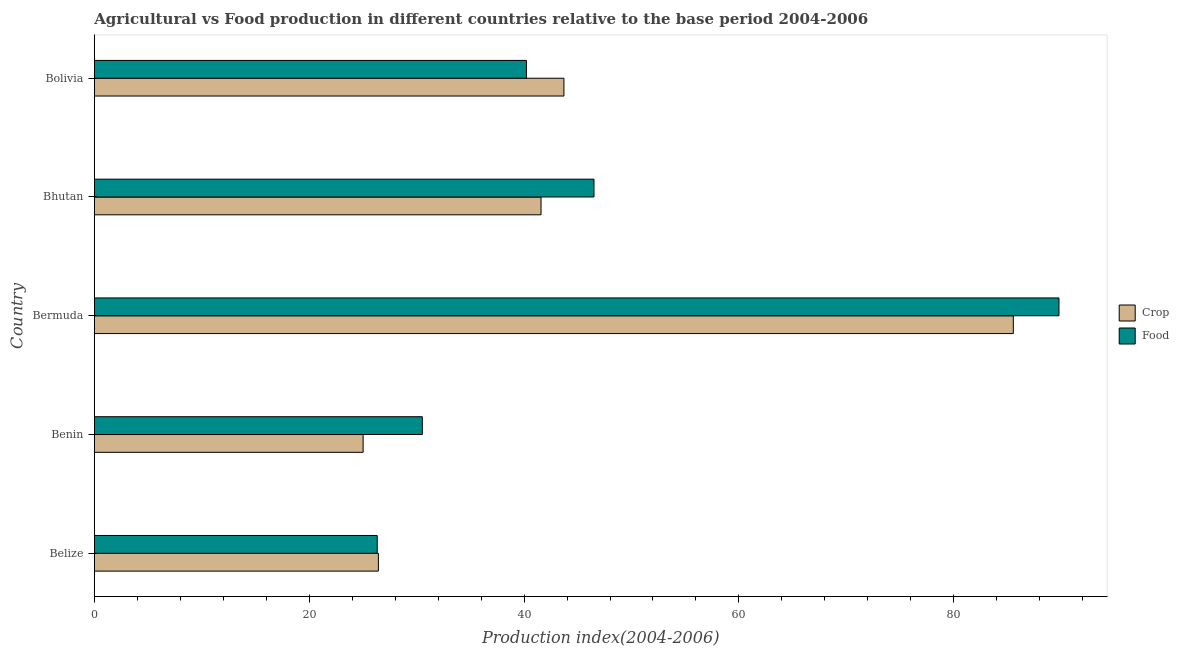How many different coloured bars are there?
Offer a terse response. 2. How many groups of bars are there?
Your response must be concise. 5. How many bars are there on the 2nd tick from the top?
Offer a terse response. 2. How many bars are there on the 1st tick from the bottom?
Offer a terse response. 2. What is the label of the 4th group of bars from the top?
Your response must be concise. Benin. What is the food production index in Benin?
Your answer should be compact. 30.53. Across all countries, what is the maximum crop production index?
Keep it short and to the point. 85.54. Across all countries, what is the minimum crop production index?
Provide a short and direct response. 25.02. In which country was the food production index maximum?
Keep it short and to the point. Bermuda. In which country was the food production index minimum?
Provide a short and direct response. Belize. What is the total crop production index in the graph?
Provide a short and direct response. 222.29. What is the difference between the food production index in Bhutan and that in Bolivia?
Give a very brief answer. 6.29. What is the difference between the food production index in Bermuda and the crop production index in Belize?
Provide a short and direct response. 63.35. What is the average food production index per country?
Your answer should be compact. 46.68. What is the difference between the food production index and crop production index in Benin?
Keep it short and to the point. 5.51. What is the ratio of the food production index in Bhutan to that in Bolivia?
Your answer should be compact. 1.16. Is the food production index in Benin less than that in Bermuda?
Give a very brief answer. Yes. What is the difference between the highest and the second highest food production index?
Provide a short and direct response. 43.28. What is the difference between the highest and the lowest crop production index?
Make the answer very short. 60.52. What does the 1st bar from the top in Bolivia represents?
Give a very brief answer. Food. What does the 1st bar from the bottom in Benin represents?
Give a very brief answer. Crop. How many bars are there?
Ensure brevity in your answer.  10. How many countries are there in the graph?
Give a very brief answer. 5. Does the graph contain any zero values?
Provide a succinct answer. No. Does the graph contain grids?
Offer a terse response. No. How many legend labels are there?
Offer a terse response. 2. What is the title of the graph?
Provide a short and direct response. Agricultural vs Food production in different countries relative to the base period 2004-2006. What is the label or title of the X-axis?
Keep it short and to the point. Production index(2004-2006). What is the Production index(2004-2006) in Crop in Belize?
Provide a short and direct response. 26.44. What is the Production index(2004-2006) in Food in Belize?
Give a very brief answer. 26.33. What is the Production index(2004-2006) in Crop in Benin?
Your response must be concise. 25.02. What is the Production index(2004-2006) in Food in Benin?
Offer a very short reply. 30.53. What is the Production index(2004-2006) in Crop in Bermuda?
Keep it short and to the point. 85.54. What is the Production index(2004-2006) in Food in Bermuda?
Provide a succinct answer. 89.79. What is the Production index(2004-2006) of Crop in Bhutan?
Keep it short and to the point. 41.58. What is the Production index(2004-2006) in Food in Bhutan?
Make the answer very short. 46.51. What is the Production index(2004-2006) of Crop in Bolivia?
Provide a short and direct response. 43.71. What is the Production index(2004-2006) of Food in Bolivia?
Give a very brief answer. 40.22. Across all countries, what is the maximum Production index(2004-2006) of Crop?
Your answer should be very brief. 85.54. Across all countries, what is the maximum Production index(2004-2006) of Food?
Offer a terse response. 89.79. Across all countries, what is the minimum Production index(2004-2006) of Crop?
Give a very brief answer. 25.02. Across all countries, what is the minimum Production index(2004-2006) of Food?
Your response must be concise. 26.33. What is the total Production index(2004-2006) in Crop in the graph?
Give a very brief answer. 222.29. What is the total Production index(2004-2006) of Food in the graph?
Keep it short and to the point. 233.38. What is the difference between the Production index(2004-2006) in Crop in Belize and that in Benin?
Make the answer very short. 1.42. What is the difference between the Production index(2004-2006) of Crop in Belize and that in Bermuda?
Keep it short and to the point. -59.1. What is the difference between the Production index(2004-2006) of Food in Belize and that in Bermuda?
Your answer should be compact. -63.46. What is the difference between the Production index(2004-2006) of Crop in Belize and that in Bhutan?
Your answer should be compact. -15.14. What is the difference between the Production index(2004-2006) in Food in Belize and that in Bhutan?
Keep it short and to the point. -20.18. What is the difference between the Production index(2004-2006) of Crop in Belize and that in Bolivia?
Give a very brief answer. -17.27. What is the difference between the Production index(2004-2006) in Food in Belize and that in Bolivia?
Provide a succinct answer. -13.89. What is the difference between the Production index(2004-2006) in Crop in Benin and that in Bermuda?
Ensure brevity in your answer.  -60.52. What is the difference between the Production index(2004-2006) of Food in Benin and that in Bermuda?
Keep it short and to the point. -59.26. What is the difference between the Production index(2004-2006) of Crop in Benin and that in Bhutan?
Give a very brief answer. -16.56. What is the difference between the Production index(2004-2006) of Food in Benin and that in Bhutan?
Your answer should be very brief. -15.98. What is the difference between the Production index(2004-2006) of Crop in Benin and that in Bolivia?
Keep it short and to the point. -18.69. What is the difference between the Production index(2004-2006) in Food in Benin and that in Bolivia?
Ensure brevity in your answer.  -9.69. What is the difference between the Production index(2004-2006) in Crop in Bermuda and that in Bhutan?
Your response must be concise. 43.96. What is the difference between the Production index(2004-2006) in Food in Bermuda and that in Bhutan?
Provide a succinct answer. 43.28. What is the difference between the Production index(2004-2006) of Crop in Bermuda and that in Bolivia?
Offer a very short reply. 41.83. What is the difference between the Production index(2004-2006) of Food in Bermuda and that in Bolivia?
Offer a very short reply. 49.57. What is the difference between the Production index(2004-2006) of Crop in Bhutan and that in Bolivia?
Keep it short and to the point. -2.13. What is the difference between the Production index(2004-2006) in Food in Bhutan and that in Bolivia?
Your response must be concise. 6.29. What is the difference between the Production index(2004-2006) in Crop in Belize and the Production index(2004-2006) in Food in Benin?
Offer a terse response. -4.09. What is the difference between the Production index(2004-2006) in Crop in Belize and the Production index(2004-2006) in Food in Bermuda?
Give a very brief answer. -63.35. What is the difference between the Production index(2004-2006) in Crop in Belize and the Production index(2004-2006) in Food in Bhutan?
Ensure brevity in your answer.  -20.07. What is the difference between the Production index(2004-2006) in Crop in Belize and the Production index(2004-2006) in Food in Bolivia?
Your response must be concise. -13.78. What is the difference between the Production index(2004-2006) of Crop in Benin and the Production index(2004-2006) of Food in Bermuda?
Offer a terse response. -64.77. What is the difference between the Production index(2004-2006) in Crop in Benin and the Production index(2004-2006) in Food in Bhutan?
Make the answer very short. -21.49. What is the difference between the Production index(2004-2006) of Crop in Benin and the Production index(2004-2006) of Food in Bolivia?
Provide a short and direct response. -15.2. What is the difference between the Production index(2004-2006) of Crop in Bermuda and the Production index(2004-2006) of Food in Bhutan?
Give a very brief answer. 39.03. What is the difference between the Production index(2004-2006) of Crop in Bermuda and the Production index(2004-2006) of Food in Bolivia?
Your response must be concise. 45.32. What is the difference between the Production index(2004-2006) of Crop in Bhutan and the Production index(2004-2006) of Food in Bolivia?
Your answer should be compact. 1.36. What is the average Production index(2004-2006) in Crop per country?
Your response must be concise. 44.46. What is the average Production index(2004-2006) of Food per country?
Offer a terse response. 46.68. What is the difference between the Production index(2004-2006) of Crop and Production index(2004-2006) of Food in Belize?
Make the answer very short. 0.11. What is the difference between the Production index(2004-2006) of Crop and Production index(2004-2006) of Food in Benin?
Give a very brief answer. -5.51. What is the difference between the Production index(2004-2006) in Crop and Production index(2004-2006) in Food in Bermuda?
Offer a terse response. -4.25. What is the difference between the Production index(2004-2006) of Crop and Production index(2004-2006) of Food in Bhutan?
Ensure brevity in your answer.  -4.93. What is the difference between the Production index(2004-2006) of Crop and Production index(2004-2006) of Food in Bolivia?
Your answer should be compact. 3.49. What is the ratio of the Production index(2004-2006) of Crop in Belize to that in Benin?
Provide a succinct answer. 1.06. What is the ratio of the Production index(2004-2006) in Food in Belize to that in Benin?
Offer a very short reply. 0.86. What is the ratio of the Production index(2004-2006) in Crop in Belize to that in Bermuda?
Give a very brief answer. 0.31. What is the ratio of the Production index(2004-2006) in Food in Belize to that in Bermuda?
Your answer should be compact. 0.29. What is the ratio of the Production index(2004-2006) in Crop in Belize to that in Bhutan?
Your response must be concise. 0.64. What is the ratio of the Production index(2004-2006) in Food in Belize to that in Bhutan?
Make the answer very short. 0.57. What is the ratio of the Production index(2004-2006) of Crop in Belize to that in Bolivia?
Your answer should be very brief. 0.6. What is the ratio of the Production index(2004-2006) of Food in Belize to that in Bolivia?
Keep it short and to the point. 0.65. What is the ratio of the Production index(2004-2006) in Crop in Benin to that in Bermuda?
Keep it short and to the point. 0.29. What is the ratio of the Production index(2004-2006) in Food in Benin to that in Bermuda?
Your answer should be compact. 0.34. What is the ratio of the Production index(2004-2006) in Crop in Benin to that in Bhutan?
Provide a succinct answer. 0.6. What is the ratio of the Production index(2004-2006) in Food in Benin to that in Bhutan?
Ensure brevity in your answer.  0.66. What is the ratio of the Production index(2004-2006) of Crop in Benin to that in Bolivia?
Provide a short and direct response. 0.57. What is the ratio of the Production index(2004-2006) in Food in Benin to that in Bolivia?
Offer a very short reply. 0.76. What is the ratio of the Production index(2004-2006) in Crop in Bermuda to that in Bhutan?
Give a very brief answer. 2.06. What is the ratio of the Production index(2004-2006) of Food in Bermuda to that in Bhutan?
Give a very brief answer. 1.93. What is the ratio of the Production index(2004-2006) in Crop in Bermuda to that in Bolivia?
Keep it short and to the point. 1.96. What is the ratio of the Production index(2004-2006) of Food in Bermuda to that in Bolivia?
Offer a very short reply. 2.23. What is the ratio of the Production index(2004-2006) in Crop in Bhutan to that in Bolivia?
Ensure brevity in your answer.  0.95. What is the ratio of the Production index(2004-2006) in Food in Bhutan to that in Bolivia?
Keep it short and to the point. 1.16. What is the difference between the highest and the second highest Production index(2004-2006) in Crop?
Provide a short and direct response. 41.83. What is the difference between the highest and the second highest Production index(2004-2006) of Food?
Provide a succinct answer. 43.28. What is the difference between the highest and the lowest Production index(2004-2006) in Crop?
Ensure brevity in your answer.  60.52. What is the difference between the highest and the lowest Production index(2004-2006) of Food?
Offer a very short reply. 63.46. 